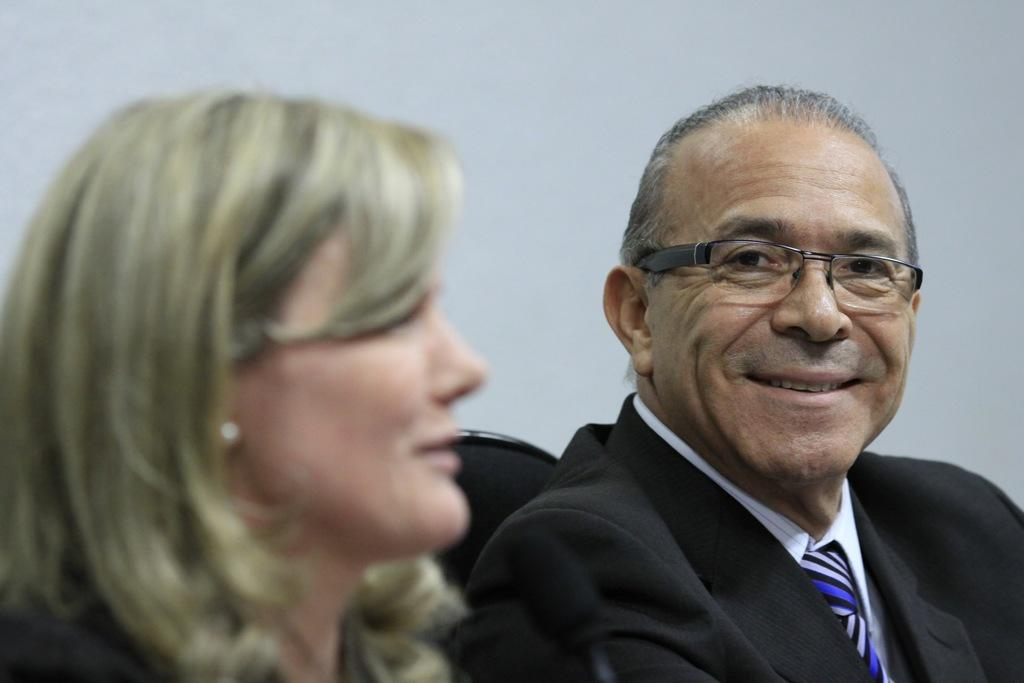What is the person in the image wearing? The person in the image is wearing a suit. What is the person in the suit doing? The person is sitting. What is the facial expression of the person in the suit? The person is smiling. Who else is present in the image? There is a woman in the image. What is the facial expression of the woman? The woman is smiling. What is the color of the background in the image? The background of the image is white in color. What type of bear can be seen interacting with the person in the suit in the image? There is no bear present in the image; it only features a person in a suit and a woman. What is the person in the suit eating for dinner in the image? There is no dinner or food visible in the image. 